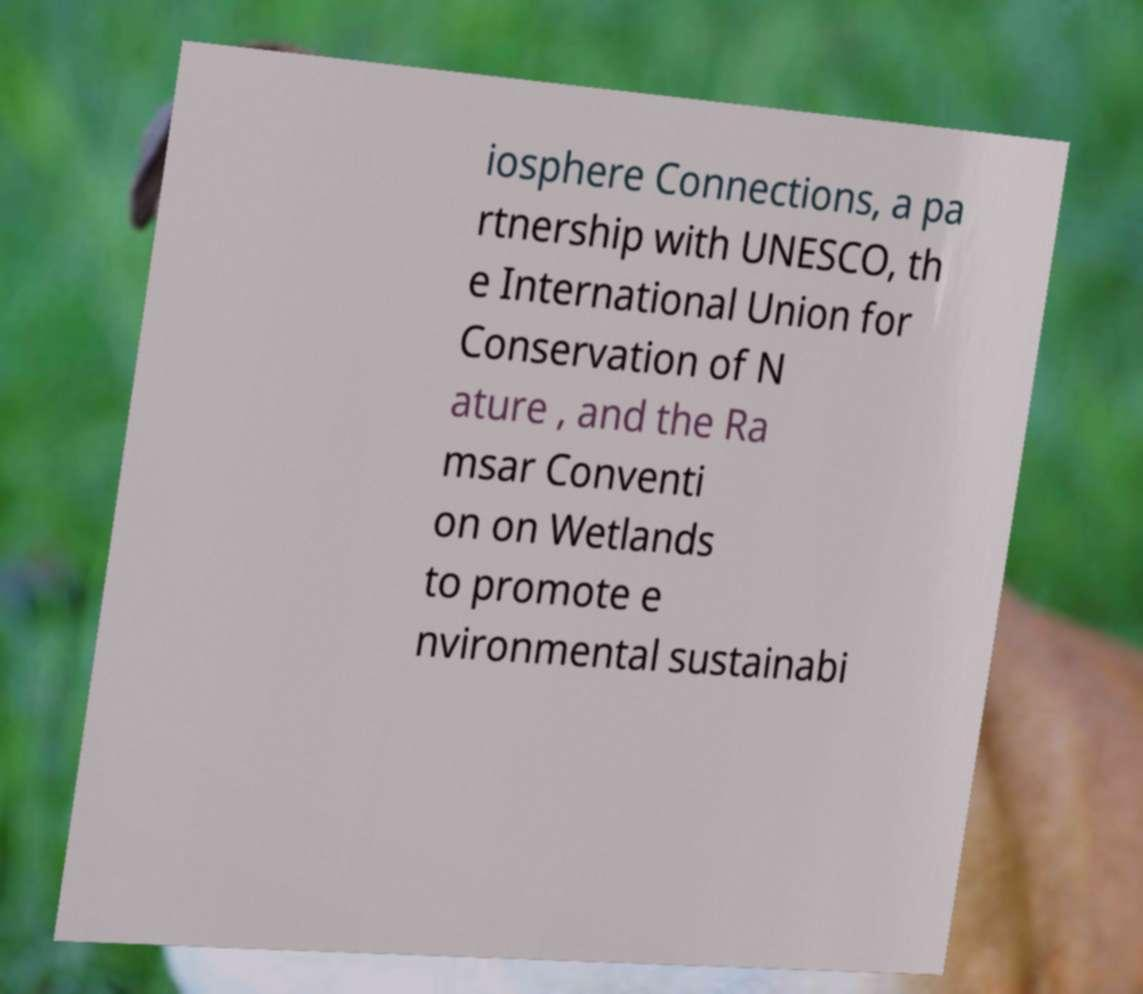Could you assist in decoding the text presented in this image and type it out clearly? iosphere Connections, a pa rtnership with UNESCO, th e International Union for Conservation of N ature , and the Ra msar Conventi on on Wetlands to promote e nvironmental sustainabi 